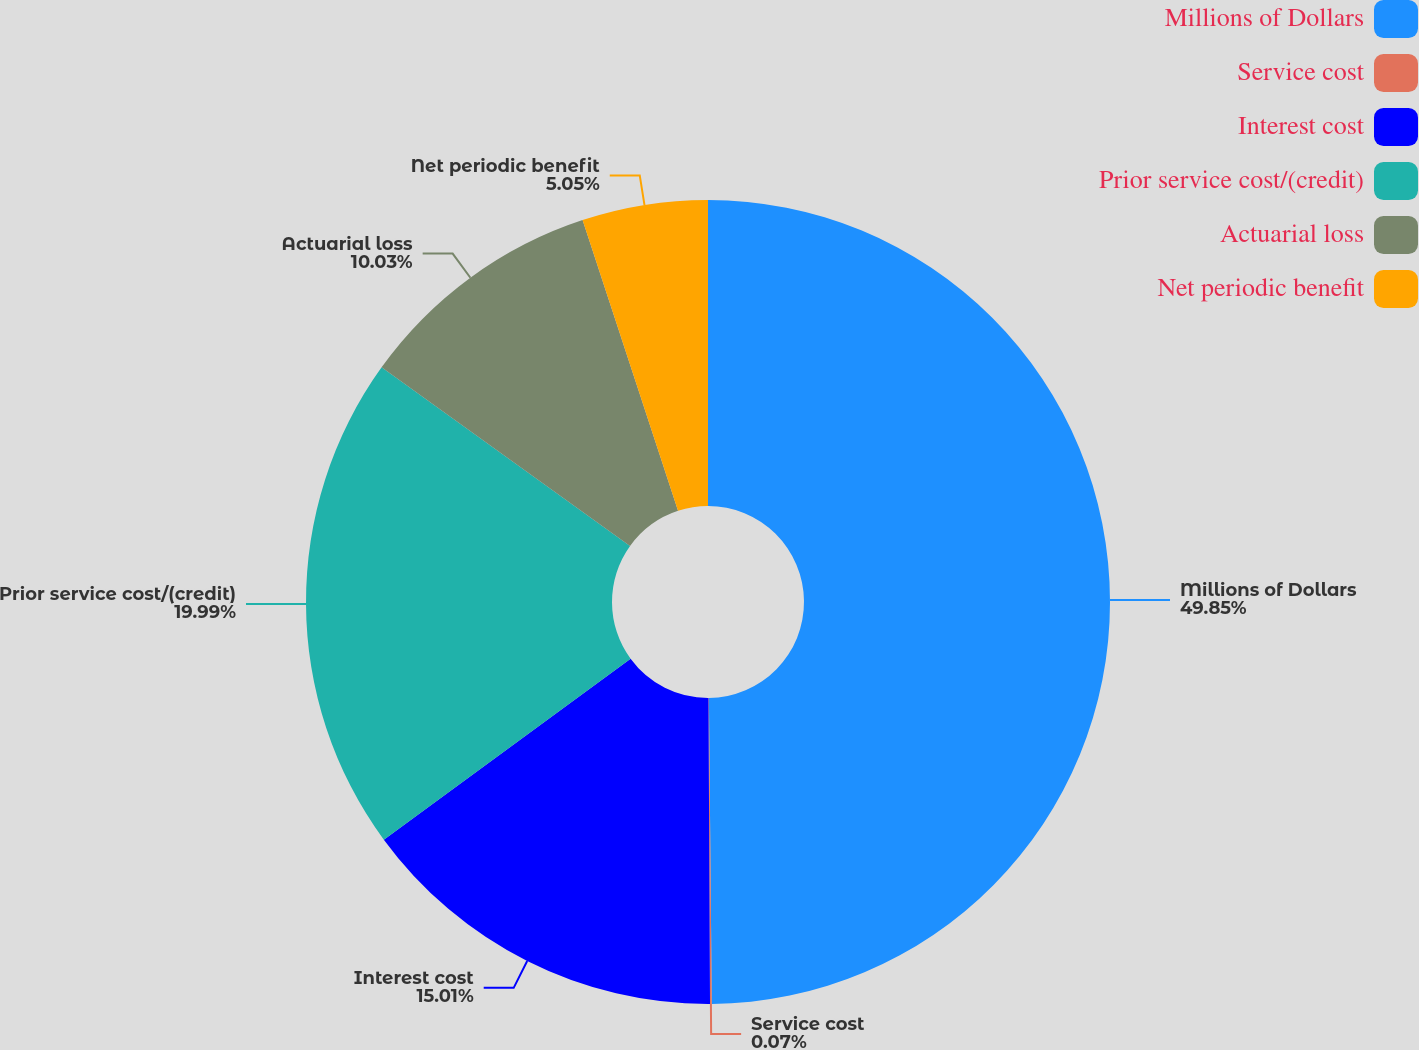Convert chart. <chart><loc_0><loc_0><loc_500><loc_500><pie_chart><fcel>Millions of Dollars<fcel>Service cost<fcel>Interest cost<fcel>Prior service cost/(credit)<fcel>Actuarial loss<fcel>Net periodic benefit<nl><fcel>49.85%<fcel>0.07%<fcel>15.01%<fcel>19.99%<fcel>10.03%<fcel>5.05%<nl></chart> 